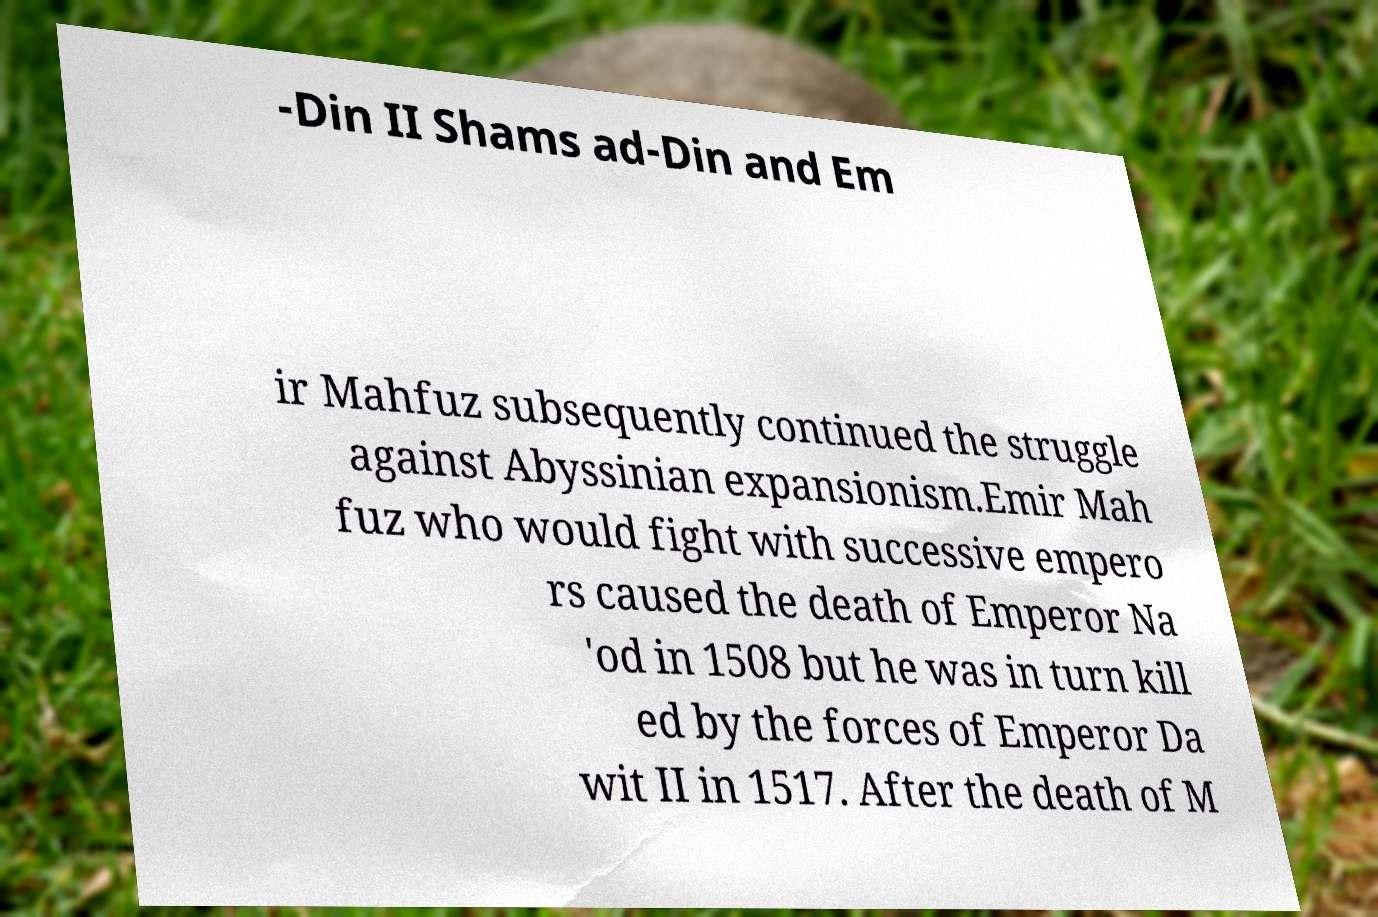Can you accurately transcribe the text from the provided image for me? -Din II Shams ad-Din and Em ir Mahfuz subsequently continued the struggle against Abyssinian expansionism.Emir Mah fuz who would fight with successive empero rs caused the death of Emperor Na 'od in 1508 but he was in turn kill ed by the forces of Emperor Da wit II in 1517. After the death of M 